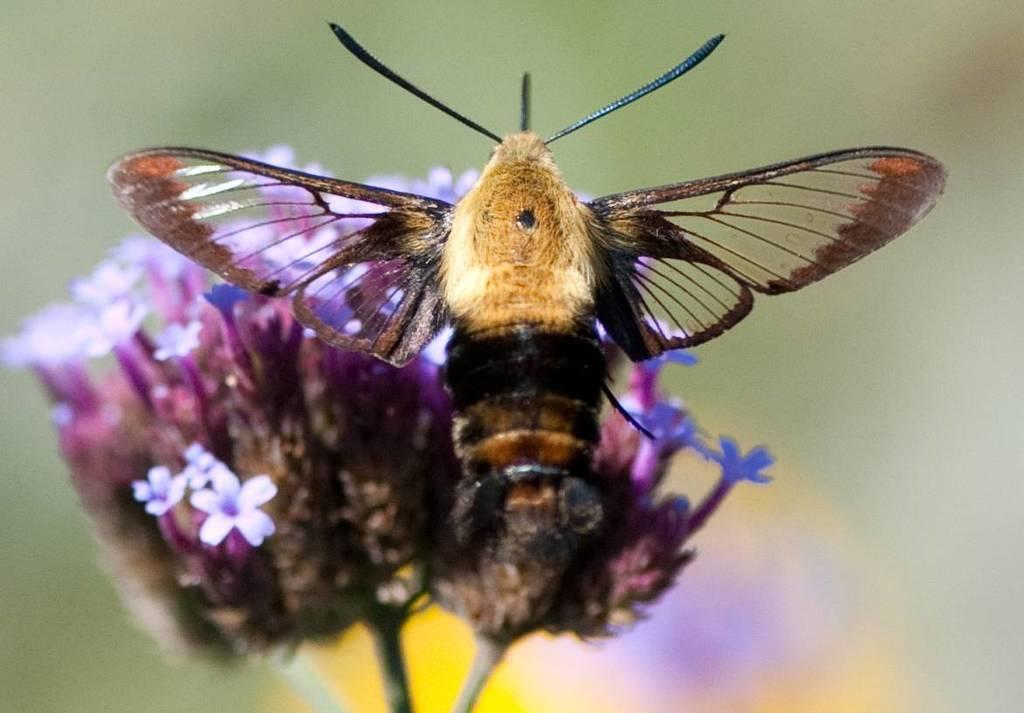What type of living organism can be seen in the image? There is an insect in the image. What other elements are present in the image besides the insect? There are flowers in the image. Can you describe the background of the image? The background of the image is blurred. What type of trousers is the insect wearing in the image? Insects do not wear trousers, as they are not human and do not have the ability to wear clothing. 